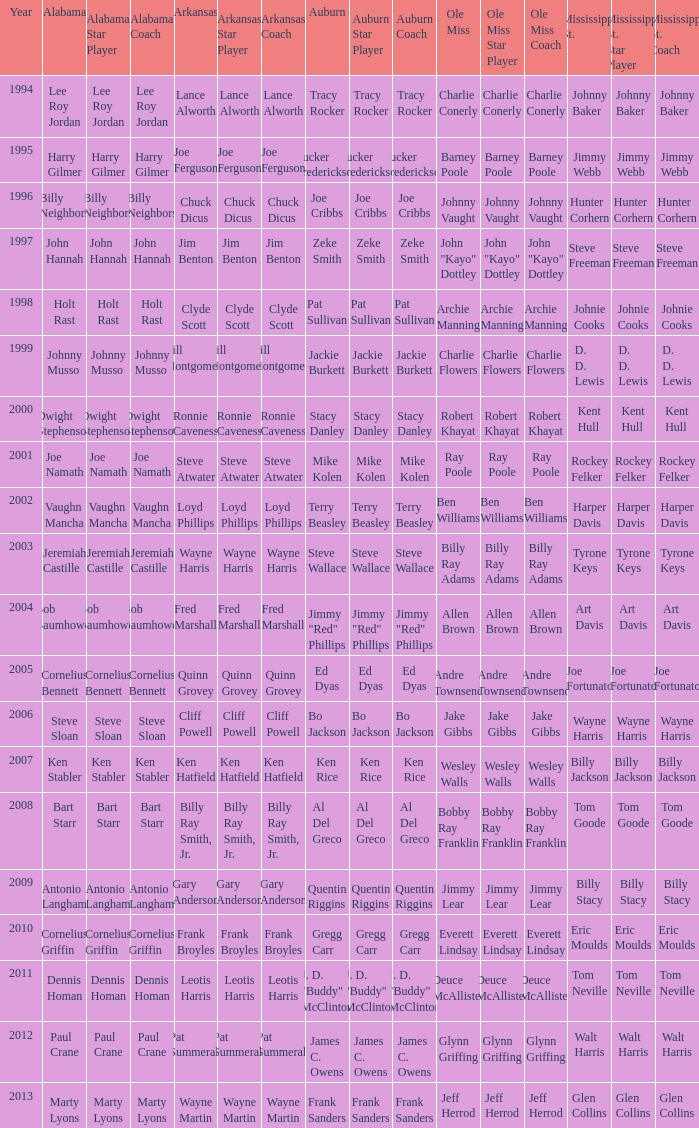Who was the Ole Miss player associated with Chuck Dicus? Johnny Vaught. 